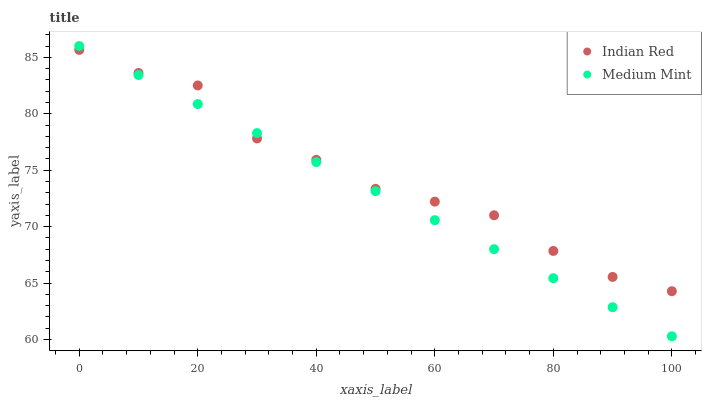Does Medium Mint have the minimum area under the curve?
Answer yes or no. Yes. Does Indian Red have the maximum area under the curve?
Answer yes or no. Yes. Does Indian Red have the minimum area under the curve?
Answer yes or no. No. Is Medium Mint the smoothest?
Answer yes or no. Yes. Is Indian Red the roughest?
Answer yes or no. Yes. Is Indian Red the smoothest?
Answer yes or no. No. Does Medium Mint have the lowest value?
Answer yes or no. Yes. Does Indian Red have the lowest value?
Answer yes or no. No. Does Medium Mint have the highest value?
Answer yes or no. Yes. Does Indian Red have the highest value?
Answer yes or no. No. Does Indian Red intersect Medium Mint?
Answer yes or no. Yes. Is Indian Red less than Medium Mint?
Answer yes or no. No. Is Indian Red greater than Medium Mint?
Answer yes or no. No. 